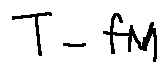Convert formula to latex. <formula><loc_0><loc_0><loc_500><loc_500>T - f M</formula> 